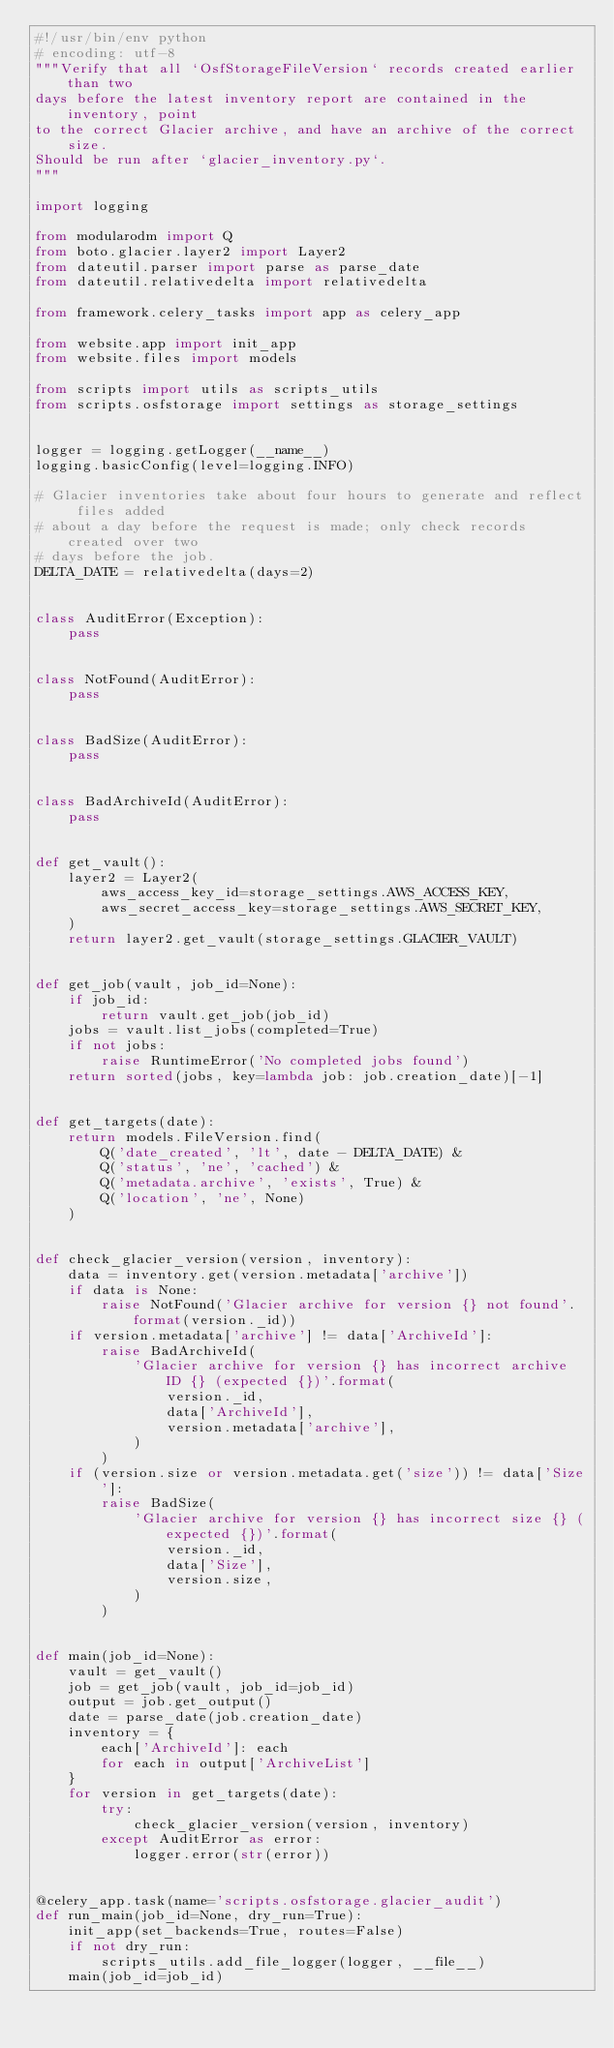Convert code to text. <code><loc_0><loc_0><loc_500><loc_500><_Python_>#!/usr/bin/env python
# encoding: utf-8
"""Verify that all `OsfStorageFileVersion` records created earlier than two
days before the latest inventory report are contained in the inventory, point
to the correct Glacier archive, and have an archive of the correct size.
Should be run after `glacier_inventory.py`.
"""

import logging

from modularodm import Q
from boto.glacier.layer2 import Layer2
from dateutil.parser import parse as parse_date
from dateutil.relativedelta import relativedelta

from framework.celery_tasks import app as celery_app

from website.app import init_app
from website.files import models

from scripts import utils as scripts_utils
from scripts.osfstorage import settings as storage_settings


logger = logging.getLogger(__name__)
logging.basicConfig(level=logging.INFO)

# Glacier inventories take about four hours to generate and reflect files added
# about a day before the request is made; only check records created over two
# days before the job.
DELTA_DATE = relativedelta(days=2)


class AuditError(Exception):
    pass


class NotFound(AuditError):
    pass


class BadSize(AuditError):
    pass


class BadArchiveId(AuditError):
    pass


def get_vault():
    layer2 = Layer2(
        aws_access_key_id=storage_settings.AWS_ACCESS_KEY,
        aws_secret_access_key=storage_settings.AWS_SECRET_KEY,
    )
    return layer2.get_vault(storage_settings.GLACIER_VAULT)


def get_job(vault, job_id=None):
    if job_id:
        return vault.get_job(job_id)
    jobs = vault.list_jobs(completed=True)
    if not jobs:
        raise RuntimeError('No completed jobs found')
    return sorted(jobs, key=lambda job: job.creation_date)[-1]


def get_targets(date):
    return models.FileVersion.find(
        Q('date_created', 'lt', date - DELTA_DATE) &
        Q('status', 'ne', 'cached') &
        Q('metadata.archive', 'exists', True) &
        Q('location', 'ne', None)
    )


def check_glacier_version(version, inventory):
    data = inventory.get(version.metadata['archive'])
    if data is None:
        raise NotFound('Glacier archive for version {} not found'.format(version._id))
    if version.metadata['archive'] != data['ArchiveId']:
        raise BadArchiveId(
            'Glacier archive for version {} has incorrect archive ID {} (expected {})'.format(
                version._id,
                data['ArchiveId'],
                version.metadata['archive'],
            )
        )
    if (version.size or version.metadata.get('size')) != data['Size']:
        raise BadSize(
            'Glacier archive for version {} has incorrect size {} (expected {})'.format(
                version._id,
                data['Size'],
                version.size,
            )
        )


def main(job_id=None):
    vault = get_vault()
    job = get_job(vault, job_id=job_id)
    output = job.get_output()
    date = parse_date(job.creation_date)
    inventory = {
        each['ArchiveId']: each
        for each in output['ArchiveList']
    }
    for version in get_targets(date):
        try:
            check_glacier_version(version, inventory)
        except AuditError as error:
            logger.error(str(error))


@celery_app.task(name='scripts.osfstorage.glacier_audit')
def run_main(job_id=None, dry_run=True):
    init_app(set_backends=True, routes=False)
    if not dry_run:
        scripts_utils.add_file_logger(logger, __file__)
    main(job_id=job_id)
</code> 